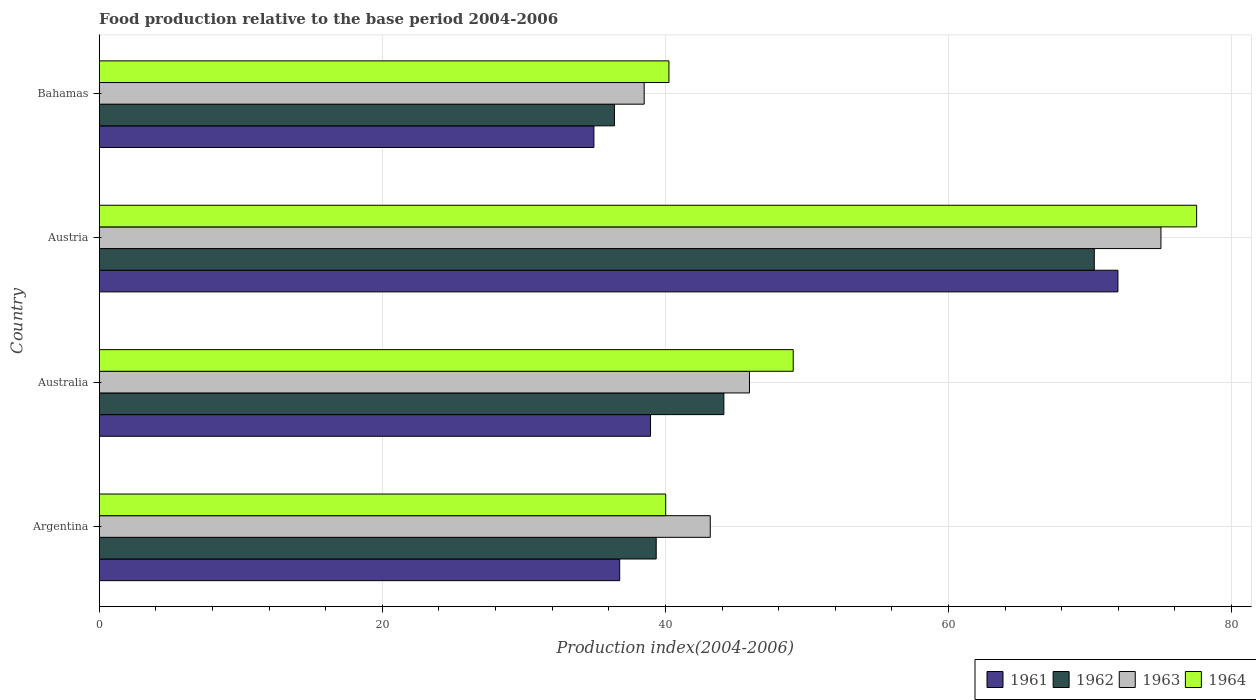How many different coloured bars are there?
Your answer should be very brief. 4. Are the number of bars per tick equal to the number of legend labels?
Offer a very short reply. Yes. Are the number of bars on each tick of the Y-axis equal?
Provide a succinct answer. Yes. In how many cases, is the number of bars for a given country not equal to the number of legend labels?
Your answer should be compact. 0. What is the food production index in 1963 in Argentina?
Provide a short and direct response. 43.17. Across all countries, what is the maximum food production index in 1964?
Provide a succinct answer. 77.53. Across all countries, what is the minimum food production index in 1963?
Make the answer very short. 38.5. In which country was the food production index in 1964 maximum?
Your answer should be compact. Austria. In which country was the food production index in 1964 minimum?
Ensure brevity in your answer.  Argentina. What is the total food production index in 1962 in the graph?
Give a very brief answer. 190.18. What is the difference between the food production index in 1962 in Argentina and that in Australia?
Your response must be concise. -4.78. What is the difference between the food production index in 1963 in Argentina and the food production index in 1961 in Bahamas?
Offer a very short reply. 8.22. What is the average food production index in 1962 per country?
Your answer should be compact. 47.55. What is the difference between the food production index in 1964 and food production index in 1962 in Argentina?
Offer a very short reply. 0.67. In how many countries, is the food production index in 1964 greater than 44 ?
Provide a succinct answer. 2. What is the ratio of the food production index in 1961 in Australia to that in Austria?
Make the answer very short. 0.54. Is the food production index in 1961 in Argentina less than that in Austria?
Your answer should be compact. Yes. Is the difference between the food production index in 1964 in Australia and Austria greater than the difference between the food production index in 1962 in Australia and Austria?
Your answer should be compact. No. What is the difference between the highest and the second highest food production index in 1961?
Your response must be concise. 33.02. What is the difference between the highest and the lowest food production index in 1963?
Make the answer very short. 36.51. In how many countries, is the food production index in 1961 greater than the average food production index in 1961 taken over all countries?
Make the answer very short. 1. Is the sum of the food production index in 1963 in Austria and Bahamas greater than the maximum food production index in 1961 across all countries?
Your answer should be compact. Yes. What does the 2nd bar from the top in Australia represents?
Provide a short and direct response. 1963. What does the 1st bar from the bottom in Austria represents?
Your response must be concise. 1961. Is it the case that in every country, the sum of the food production index in 1962 and food production index in 1964 is greater than the food production index in 1963?
Keep it short and to the point. Yes. How many bars are there?
Your response must be concise. 16. How many countries are there in the graph?
Give a very brief answer. 4. What is the difference between two consecutive major ticks on the X-axis?
Keep it short and to the point. 20. Does the graph contain any zero values?
Give a very brief answer. No. Does the graph contain grids?
Offer a very short reply. Yes. How many legend labels are there?
Your answer should be very brief. 4. What is the title of the graph?
Offer a very short reply. Food production relative to the base period 2004-2006. Does "2012" appear as one of the legend labels in the graph?
Provide a succinct answer. No. What is the label or title of the X-axis?
Your response must be concise. Production index(2004-2006). What is the label or title of the Y-axis?
Offer a terse response. Country. What is the Production index(2004-2006) in 1961 in Argentina?
Keep it short and to the point. 36.77. What is the Production index(2004-2006) in 1962 in Argentina?
Keep it short and to the point. 39.35. What is the Production index(2004-2006) of 1963 in Argentina?
Keep it short and to the point. 43.17. What is the Production index(2004-2006) in 1964 in Argentina?
Keep it short and to the point. 40.02. What is the Production index(2004-2006) in 1961 in Australia?
Keep it short and to the point. 38.95. What is the Production index(2004-2006) of 1962 in Australia?
Your answer should be compact. 44.13. What is the Production index(2004-2006) of 1963 in Australia?
Ensure brevity in your answer.  45.94. What is the Production index(2004-2006) of 1964 in Australia?
Provide a succinct answer. 49.03. What is the Production index(2004-2006) in 1961 in Austria?
Provide a short and direct response. 71.97. What is the Production index(2004-2006) of 1962 in Austria?
Your answer should be compact. 70.3. What is the Production index(2004-2006) in 1963 in Austria?
Offer a terse response. 75.01. What is the Production index(2004-2006) in 1964 in Austria?
Your answer should be compact. 77.53. What is the Production index(2004-2006) of 1961 in Bahamas?
Your answer should be compact. 34.95. What is the Production index(2004-2006) of 1962 in Bahamas?
Offer a terse response. 36.4. What is the Production index(2004-2006) of 1963 in Bahamas?
Your answer should be compact. 38.5. What is the Production index(2004-2006) of 1964 in Bahamas?
Keep it short and to the point. 40.25. Across all countries, what is the maximum Production index(2004-2006) of 1961?
Give a very brief answer. 71.97. Across all countries, what is the maximum Production index(2004-2006) in 1962?
Provide a short and direct response. 70.3. Across all countries, what is the maximum Production index(2004-2006) of 1963?
Your answer should be compact. 75.01. Across all countries, what is the maximum Production index(2004-2006) of 1964?
Your answer should be very brief. 77.53. Across all countries, what is the minimum Production index(2004-2006) in 1961?
Offer a very short reply. 34.95. Across all countries, what is the minimum Production index(2004-2006) of 1962?
Provide a succinct answer. 36.4. Across all countries, what is the minimum Production index(2004-2006) in 1963?
Provide a succinct answer. 38.5. Across all countries, what is the minimum Production index(2004-2006) in 1964?
Keep it short and to the point. 40.02. What is the total Production index(2004-2006) of 1961 in the graph?
Your answer should be very brief. 182.64. What is the total Production index(2004-2006) in 1962 in the graph?
Give a very brief answer. 190.18. What is the total Production index(2004-2006) of 1963 in the graph?
Make the answer very short. 202.62. What is the total Production index(2004-2006) in 1964 in the graph?
Keep it short and to the point. 206.83. What is the difference between the Production index(2004-2006) of 1961 in Argentina and that in Australia?
Give a very brief answer. -2.18. What is the difference between the Production index(2004-2006) in 1962 in Argentina and that in Australia?
Offer a very short reply. -4.78. What is the difference between the Production index(2004-2006) in 1963 in Argentina and that in Australia?
Offer a terse response. -2.77. What is the difference between the Production index(2004-2006) of 1964 in Argentina and that in Australia?
Ensure brevity in your answer.  -9.01. What is the difference between the Production index(2004-2006) in 1961 in Argentina and that in Austria?
Make the answer very short. -35.2. What is the difference between the Production index(2004-2006) in 1962 in Argentina and that in Austria?
Keep it short and to the point. -30.95. What is the difference between the Production index(2004-2006) of 1963 in Argentina and that in Austria?
Ensure brevity in your answer.  -31.84. What is the difference between the Production index(2004-2006) of 1964 in Argentina and that in Austria?
Provide a short and direct response. -37.51. What is the difference between the Production index(2004-2006) of 1961 in Argentina and that in Bahamas?
Your response must be concise. 1.82. What is the difference between the Production index(2004-2006) of 1962 in Argentina and that in Bahamas?
Your answer should be very brief. 2.95. What is the difference between the Production index(2004-2006) of 1963 in Argentina and that in Bahamas?
Your answer should be very brief. 4.67. What is the difference between the Production index(2004-2006) in 1964 in Argentina and that in Bahamas?
Your answer should be compact. -0.23. What is the difference between the Production index(2004-2006) of 1961 in Australia and that in Austria?
Ensure brevity in your answer.  -33.02. What is the difference between the Production index(2004-2006) of 1962 in Australia and that in Austria?
Provide a short and direct response. -26.17. What is the difference between the Production index(2004-2006) in 1963 in Australia and that in Austria?
Keep it short and to the point. -29.07. What is the difference between the Production index(2004-2006) of 1964 in Australia and that in Austria?
Offer a very short reply. -28.5. What is the difference between the Production index(2004-2006) of 1962 in Australia and that in Bahamas?
Offer a terse response. 7.73. What is the difference between the Production index(2004-2006) of 1963 in Australia and that in Bahamas?
Your response must be concise. 7.44. What is the difference between the Production index(2004-2006) of 1964 in Australia and that in Bahamas?
Your answer should be very brief. 8.78. What is the difference between the Production index(2004-2006) of 1961 in Austria and that in Bahamas?
Your answer should be very brief. 37.02. What is the difference between the Production index(2004-2006) of 1962 in Austria and that in Bahamas?
Make the answer very short. 33.9. What is the difference between the Production index(2004-2006) of 1963 in Austria and that in Bahamas?
Give a very brief answer. 36.51. What is the difference between the Production index(2004-2006) of 1964 in Austria and that in Bahamas?
Keep it short and to the point. 37.28. What is the difference between the Production index(2004-2006) in 1961 in Argentina and the Production index(2004-2006) in 1962 in Australia?
Give a very brief answer. -7.36. What is the difference between the Production index(2004-2006) of 1961 in Argentina and the Production index(2004-2006) of 1963 in Australia?
Offer a very short reply. -9.17. What is the difference between the Production index(2004-2006) of 1961 in Argentina and the Production index(2004-2006) of 1964 in Australia?
Your answer should be compact. -12.26. What is the difference between the Production index(2004-2006) in 1962 in Argentina and the Production index(2004-2006) in 1963 in Australia?
Keep it short and to the point. -6.59. What is the difference between the Production index(2004-2006) of 1962 in Argentina and the Production index(2004-2006) of 1964 in Australia?
Your response must be concise. -9.68. What is the difference between the Production index(2004-2006) of 1963 in Argentina and the Production index(2004-2006) of 1964 in Australia?
Keep it short and to the point. -5.86. What is the difference between the Production index(2004-2006) in 1961 in Argentina and the Production index(2004-2006) in 1962 in Austria?
Keep it short and to the point. -33.53. What is the difference between the Production index(2004-2006) in 1961 in Argentina and the Production index(2004-2006) in 1963 in Austria?
Your answer should be very brief. -38.24. What is the difference between the Production index(2004-2006) in 1961 in Argentina and the Production index(2004-2006) in 1964 in Austria?
Your answer should be very brief. -40.76. What is the difference between the Production index(2004-2006) of 1962 in Argentina and the Production index(2004-2006) of 1963 in Austria?
Ensure brevity in your answer.  -35.66. What is the difference between the Production index(2004-2006) of 1962 in Argentina and the Production index(2004-2006) of 1964 in Austria?
Keep it short and to the point. -38.18. What is the difference between the Production index(2004-2006) in 1963 in Argentina and the Production index(2004-2006) in 1964 in Austria?
Your answer should be very brief. -34.36. What is the difference between the Production index(2004-2006) of 1961 in Argentina and the Production index(2004-2006) of 1962 in Bahamas?
Keep it short and to the point. 0.37. What is the difference between the Production index(2004-2006) in 1961 in Argentina and the Production index(2004-2006) in 1963 in Bahamas?
Offer a very short reply. -1.73. What is the difference between the Production index(2004-2006) in 1961 in Argentina and the Production index(2004-2006) in 1964 in Bahamas?
Provide a short and direct response. -3.48. What is the difference between the Production index(2004-2006) in 1962 in Argentina and the Production index(2004-2006) in 1963 in Bahamas?
Provide a succinct answer. 0.85. What is the difference between the Production index(2004-2006) of 1963 in Argentina and the Production index(2004-2006) of 1964 in Bahamas?
Make the answer very short. 2.92. What is the difference between the Production index(2004-2006) of 1961 in Australia and the Production index(2004-2006) of 1962 in Austria?
Give a very brief answer. -31.35. What is the difference between the Production index(2004-2006) of 1961 in Australia and the Production index(2004-2006) of 1963 in Austria?
Offer a terse response. -36.06. What is the difference between the Production index(2004-2006) in 1961 in Australia and the Production index(2004-2006) in 1964 in Austria?
Provide a succinct answer. -38.58. What is the difference between the Production index(2004-2006) in 1962 in Australia and the Production index(2004-2006) in 1963 in Austria?
Provide a short and direct response. -30.88. What is the difference between the Production index(2004-2006) in 1962 in Australia and the Production index(2004-2006) in 1964 in Austria?
Make the answer very short. -33.4. What is the difference between the Production index(2004-2006) of 1963 in Australia and the Production index(2004-2006) of 1964 in Austria?
Give a very brief answer. -31.59. What is the difference between the Production index(2004-2006) in 1961 in Australia and the Production index(2004-2006) in 1962 in Bahamas?
Offer a terse response. 2.55. What is the difference between the Production index(2004-2006) in 1961 in Australia and the Production index(2004-2006) in 1963 in Bahamas?
Give a very brief answer. 0.45. What is the difference between the Production index(2004-2006) in 1961 in Australia and the Production index(2004-2006) in 1964 in Bahamas?
Ensure brevity in your answer.  -1.3. What is the difference between the Production index(2004-2006) of 1962 in Australia and the Production index(2004-2006) of 1963 in Bahamas?
Provide a succinct answer. 5.63. What is the difference between the Production index(2004-2006) of 1962 in Australia and the Production index(2004-2006) of 1964 in Bahamas?
Give a very brief answer. 3.88. What is the difference between the Production index(2004-2006) of 1963 in Australia and the Production index(2004-2006) of 1964 in Bahamas?
Give a very brief answer. 5.69. What is the difference between the Production index(2004-2006) in 1961 in Austria and the Production index(2004-2006) in 1962 in Bahamas?
Your answer should be very brief. 35.57. What is the difference between the Production index(2004-2006) of 1961 in Austria and the Production index(2004-2006) of 1963 in Bahamas?
Your response must be concise. 33.47. What is the difference between the Production index(2004-2006) of 1961 in Austria and the Production index(2004-2006) of 1964 in Bahamas?
Give a very brief answer. 31.72. What is the difference between the Production index(2004-2006) in 1962 in Austria and the Production index(2004-2006) in 1963 in Bahamas?
Your response must be concise. 31.8. What is the difference between the Production index(2004-2006) of 1962 in Austria and the Production index(2004-2006) of 1964 in Bahamas?
Make the answer very short. 30.05. What is the difference between the Production index(2004-2006) in 1963 in Austria and the Production index(2004-2006) in 1964 in Bahamas?
Make the answer very short. 34.76. What is the average Production index(2004-2006) in 1961 per country?
Ensure brevity in your answer.  45.66. What is the average Production index(2004-2006) of 1962 per country?
Provide a succinct answer. 47.55. What is the average Production index(2004-2006) in 1963 per country?
Give a very brief answer. 50.66. What is the average Production index(2004-2006) of 1964 per country?
Provide a succinct answer. 51.71. What is the difference between the Production index(2004-2006) in 1961 and Production index(2004-2006) in 1962 in Argentina?
Provide a succinct answer. -2.58. What is the difference between the Production index(2004-2006) in 1961 and Production index(2004-2006) in 1963 in Argentina?
Give a very brief answer. -6.4. What is the difference between the Production index(2004-2006) in 1961 and Production index(2004-2006) in 1964 in Argentina?
Offer a very short reply. -3.25. What is the difference between the Production index(2004-2006) in 1962 and Production index(2004-2006) in 1963 in Argentina?
Keep it short and to the point. -3.82. What is the difference between the Production index(2004-2006) in 1962 and Production index(2004-2006) in 1964 in Argentina?
Your response must be concise. -0.67. What is the difference between the Production index(2004-2006) in 1963 and Production index(2004-2006) in 1964 in Argentina?
Your response must be concise. 3.15. What is the difference between the Production index(2004-2006) of 1961 and Production index(2004-2006) of 1962 in Australia?
Keep it short and to the point. -5.18. What is the difference between the Production index(2004-2006) of 1961 and Production index(2004-2006) of 1963 in Australia?
Your answer should be compact. -6.99. What is the difference between the Production index(2004-2006) in 1961 and Production index(2004-2006) in 1964 in Australia?
Your response must be concise. -10.08. What is the difference between the Production index(2004-2006) in 1962 and Production index(2004-2006) in 1963 in Australia?
Give a very brief answer. -1.81. What is the difference between the Production index(2004-2006) in 1962 and Production index(2004-2006) in 1964 in Australia?
Offer a very short reply. -4.9. What is the difference between the Production index(2004-2006) in 1963 and Production index(2004-2006) in 1964 in Australia?
Offer a terse response. -3.09. What is the difference between the Production index(2004-2006) of 1961 and Production index(2004-2006) of 1962 in Austria?
Your answer should be very brief. 1.67. What is the difference between the Production index(2004-2006) of 1961 and Production index(2004-2006) of 1963 in Austria?
Keep it short and to the point. -3.04. What is the difference between the Production index(2004-2006) of 1961 and Production index(2004-2006) of 1964 in Austria?
Give a very brief answer. -5.56. What is the difference between the Production index(2004-2006) in 1962 and Production index(2004-2006) in 1963 in Austria?
Provide a succinct answer. -4.71. What is the difference between the Production index(2004-2006) of 1962 and Production index(2004-2006) of 1964 in Austria?
Provide a short and direct response. -7.23. What is the difference between the Production index(2004-2006) of 1963 and Production index(2004-2006) of 1964 in Austria?
Provide a succinct answer. -2.52. What is the difference between the Production index(2004-2006) of 1961 and Production index(2004-2006) of 1962 in Bahamas?
Your answer should be compact. -1.45. What is the difference between the Production index(2004-2006) of 1961 and Production index(2004-2006) of 1963 in Bahamas?
Your response must be concise. -3.55. What is the difference between the Production index(2004-2006) of 1962 and Production index(2004-2006) of 1964 in Bahamas?
Offer a terse response. -3.85. What is the difference between the Production index(2004-2006) in 1963 and Production index(2004-2006) in 1964 in Bahamas?
Ensure brevity in your answer.  -1.75. What is the ratio of the Production index(2004-2006) in 1961 in Argentina to that in Australia?
Provide a succinct answer. 0.94. What is the ratio of the Production index(2004-2006) of 1962 in Argentina to that in Australia?
Your response must be concise. 0.89. What is the ratio of the Production index(2004-2006) in 1963 in Argentina to that in Australia?
Keep it short and to the point. 0.94. What is the ratio of the Production index(2004-2006) in 1964 in Argentina to that in Australia?
Your answer should be compact. 0.82. What is the ratio of the Production index(2004-2006) of 1961 in Argentina to that in Austria?
Your response must be concise. 0.51. What is the ratio of the Production index(2004-2006) of 1962 in Argentina to that in Austria?
Ensure brevity in your answer.  0.56. What is the ratio of the Production index(2004-2006) of 1963 in Argentina to that in Austria?
Provide a short and direct response. 0.58. What is the ratio of the Production index(2004-2006) of 1964 in Argentina to that in Austria?
Provide a short and direct response. 0.52. What is the ratio of the Production index(2004-2006) in 1961 in Argentina to that in Bahamas?
Your response must be concise. 1.05. What is the ratio of the Production index(2004-2006) in 1962 in Argentina to that in Bahamas?
Offer a very short reply. 1.08. What is the ratio of the Production index(2004-2006) of 1963 in Argentina to that in Bahamas?
Provide a short and direct response. 1.12. What is the ratio of the Production index(2004-2006) of 1961 in Australia to that in Austria?
Keep it short and to the point. 0.54. What is the ratio of the Production index(2004-2006) in 1962 in Australia to that in Austria?
Provide a succinct answer. 0.63. What is the ratio of the Production index(2004-2006) in 1963 in Australia to that in Austria?
Provide a succinct answer. 0.61. What is the ratio of the Production index(2004-2006) of 1964 in Australia to that in Austria?
Offer a terse response. 0.63. What is the ratio of the Production index(2004-2006) of 1961 in Australia to that in Bahamas?
Provide a short and direct response. 1.11. What is the ratio of the Production index(2004-2006) of 1962 in Australia to that in Bahamas?
Provide a succinct answer. 1.21. What is the ratio of the Production index(2004-2006) of 1963 in Australia to that in Bahamas?
Offer a very short reply. 1.19. What is the ratio of the Production index(2004-2006) in 1964 in Australia to that in Bahamas?
Keep it short and to the point. 1.22. What is the ratio of the Production index(2004-2006) in 1961 in Austria to that in Bahamas?
Make the answer very short. 2.06. What is the ratio of the Production index(2004-2006) in 1962 in Austria to that in Bahamas?
Keep it short and to the point. 1.93. What is the ratio of the Production index(2004-2006) of 1963 in Austria to that in Bahamas?
Your response must be concise. 1.95. What is the ratio of the Production index(2004-2006) of 1964 in Austria to that in Bahamas?
Offer a terse response. 1.93. What is the difference between the highest and the second highest Production index(2004-2006) in 1961?
Make the answer very short. 33.02. What is the difference between the highest and the second highest Production index(2004-2006) of 1962?
Keep it short and to the point. 26.17. What is the difference between the highest and the second highest Production index(2004-2006) in 1963?
Give a very brief answer. 29.07. What is the difference between the highest and the second highest Production index(2004-2006) of 1964?
Your answer should be very brief. 28.5. What is the difference between the highest and the lowest Production index(2004-2006) of 1961?
Your answer should be very brief. 37.02. What is the difference between the highest and the lowest Production index(2004-2006) in 1962?
Offer a very short reply. 33.9. What is the difference between the highest and the lowest Production index(2004-2006) of 1963?
Your response must be concise. 36.51. What is the difference between the highest and the lowest Production index(2004-2006) in 1964?
Give a very brief answer. 37.51. 